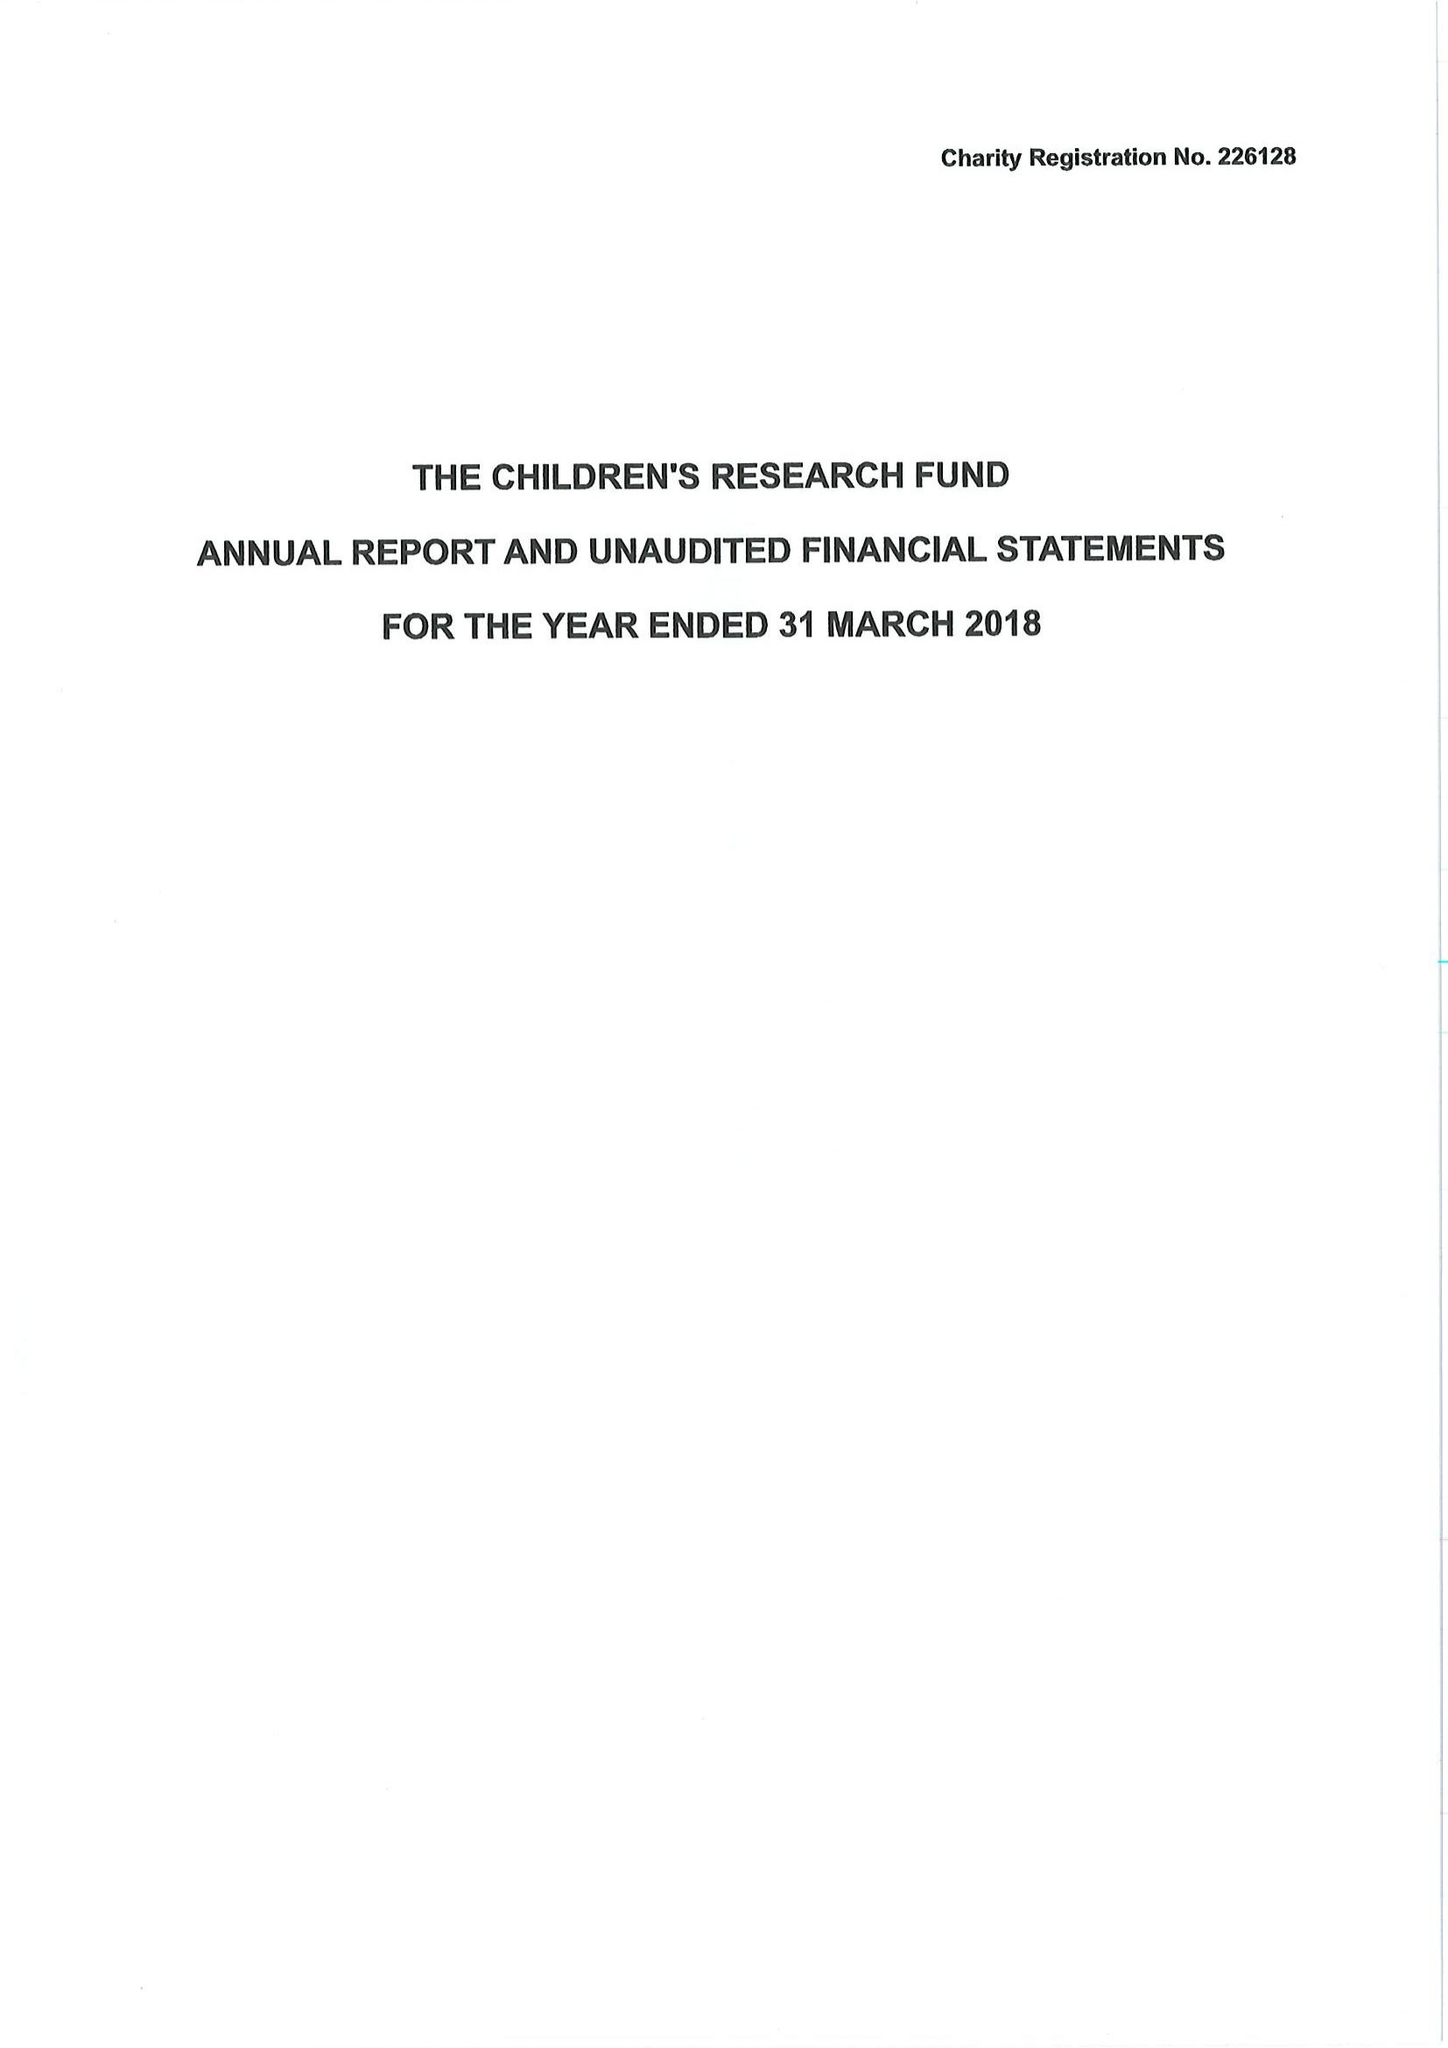What is the value for the address__postcode?
Answer the question using a single word or phrase. LL15 1AQ 